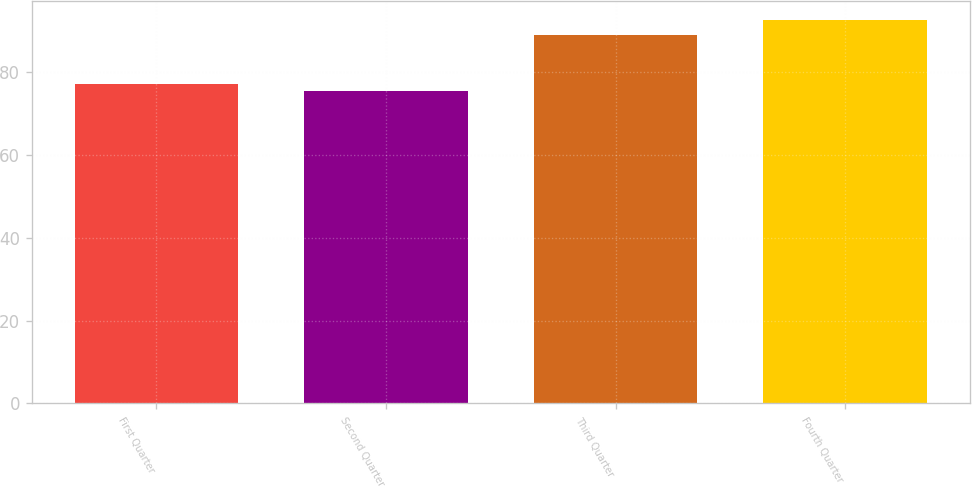<chart> <loc_0><loc_0><loc_500><loc_500><bar_chart><fcel>First Quarter<fcel>Second Quarter<fcel>Third Quarter<fcel>Fourth Quarter<nl><fcel>77.23<fcel>75.54<fcel>88.99<fcel>92.49<nl></chart> 